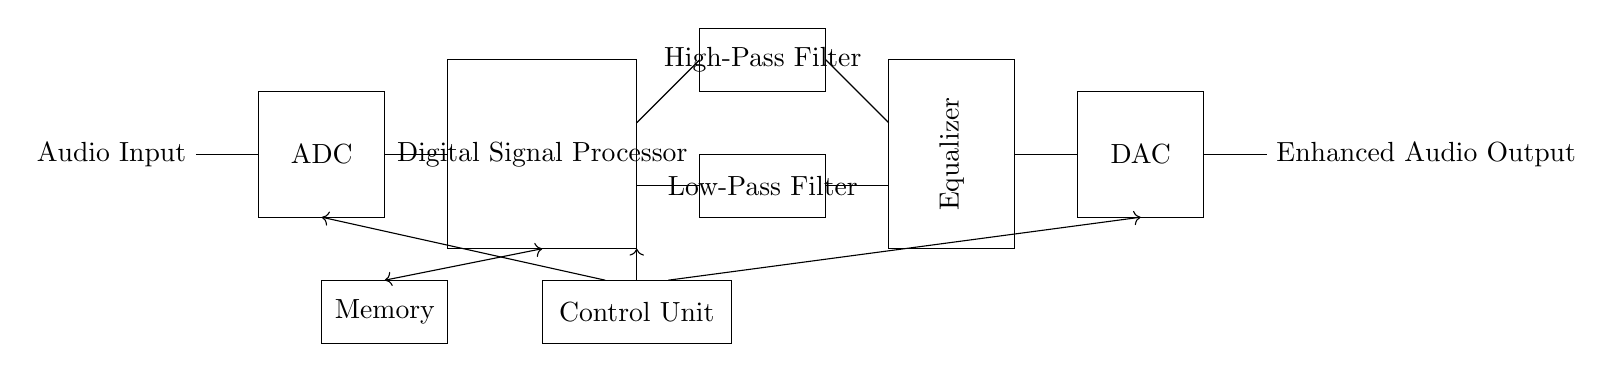what is the first component in the circuit? The first component is the Audio Input, which is the source of the audio signal that will be processed.
Answer: Audio Input what does the DSP stand for in this circuit? DSP stands for Digital Signal Processor, which is the component responsible for processing the audio signal using various algorithms to enhance sound quality and effects.
Answer: Digital Signal Processor which two filters are included in the circuit? The circuit includes a High-Pass Filter and a Low-Pass Filter, which are used to allow certain frequency ranges to pass through while attenuating others, crucial for audio clarity.
Answer: High-Pass Filter and Low-Pass Filter how many main blocks are there in the circuit? There are five main blocks in the circuit: Audio Input, ADC, DSP, DAC, and Output. Each block plays a distinct role in the audio processing pathway.
Answer: Five what signal conversion occurs between the ADC and DAC? The signal conversion that occurs is from analog to digital at the ADC and back from digital to analog at the DAC, enabling the processing of audio data in a digital format.
Answer: Analog to Digital and Digital to Analog what role does the Control Unit play in the circuit? The Control Unit directs the operation of the DSP and manages the flow of data between components, ensuring that the audio processing happens in an organized manner.
Answer: Directs operation how does memory interact with the DSP in this circuit? The Memory component stores data required by the DSP and allows the processor to retrieve and manipulate audio information quickly, enhancing the processing capabilities.
Answer: Stores data for DSP 